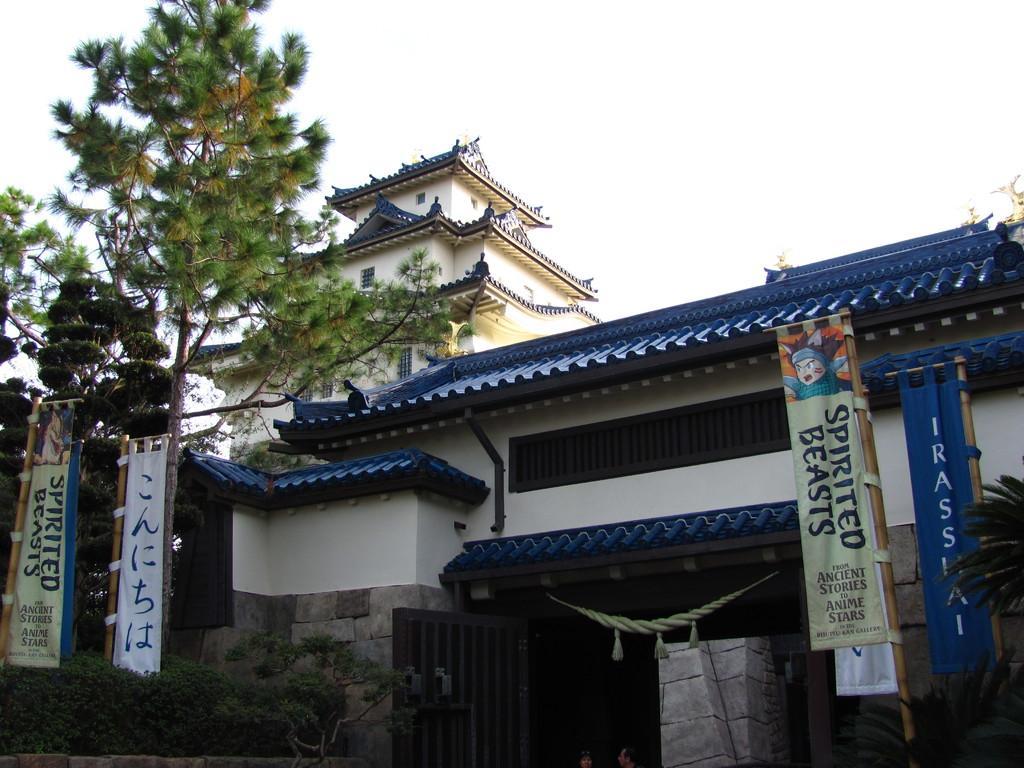How would you summarize this image in a sentence or two? In this image we can see small plants, shrubs, stone wall, banners to the wooden sticks, gate, Chinese architecture, trees and the sky in the background. 